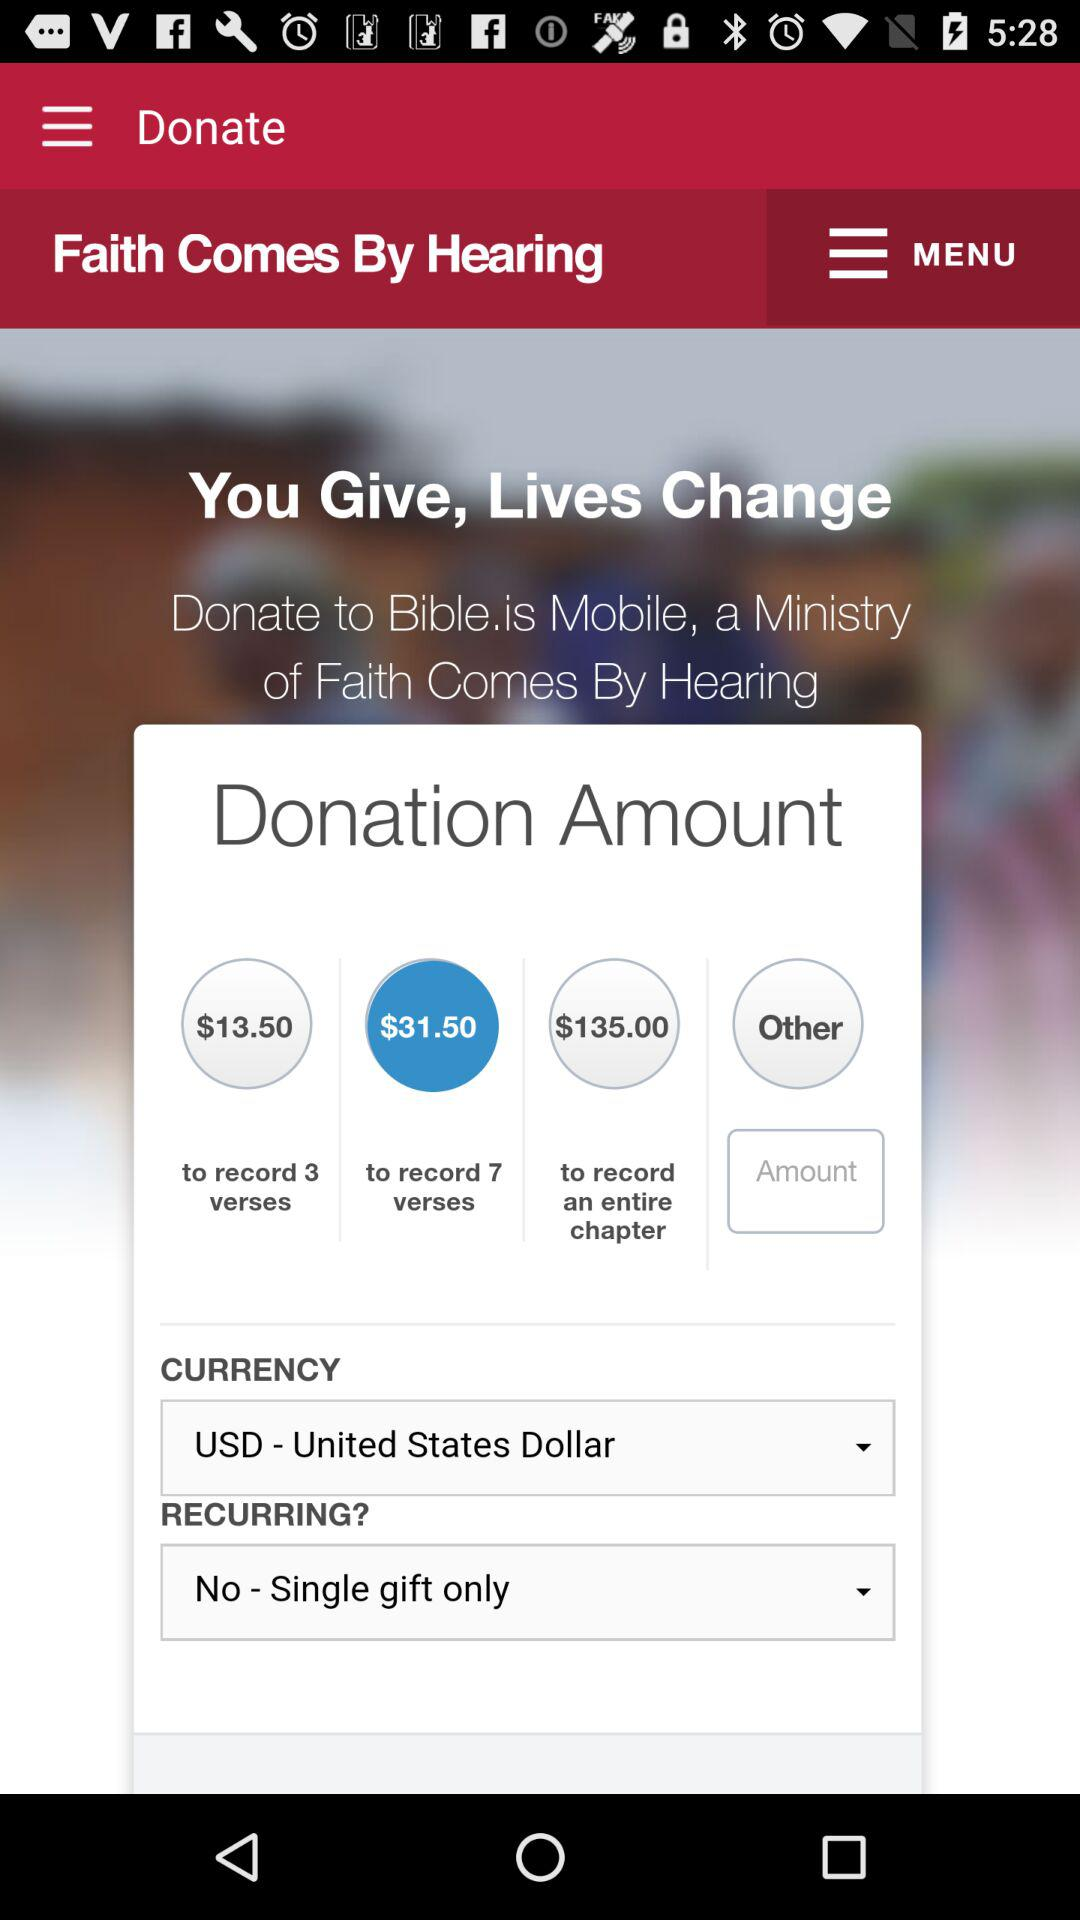What is the currency? The currency is the United States dollars. 